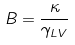Convert formula to latex. <formula><loc_0><loc_0><loc_500><loc_500>B = { \frac { \kappa } { \gamma _ { L V } } }</formula> 